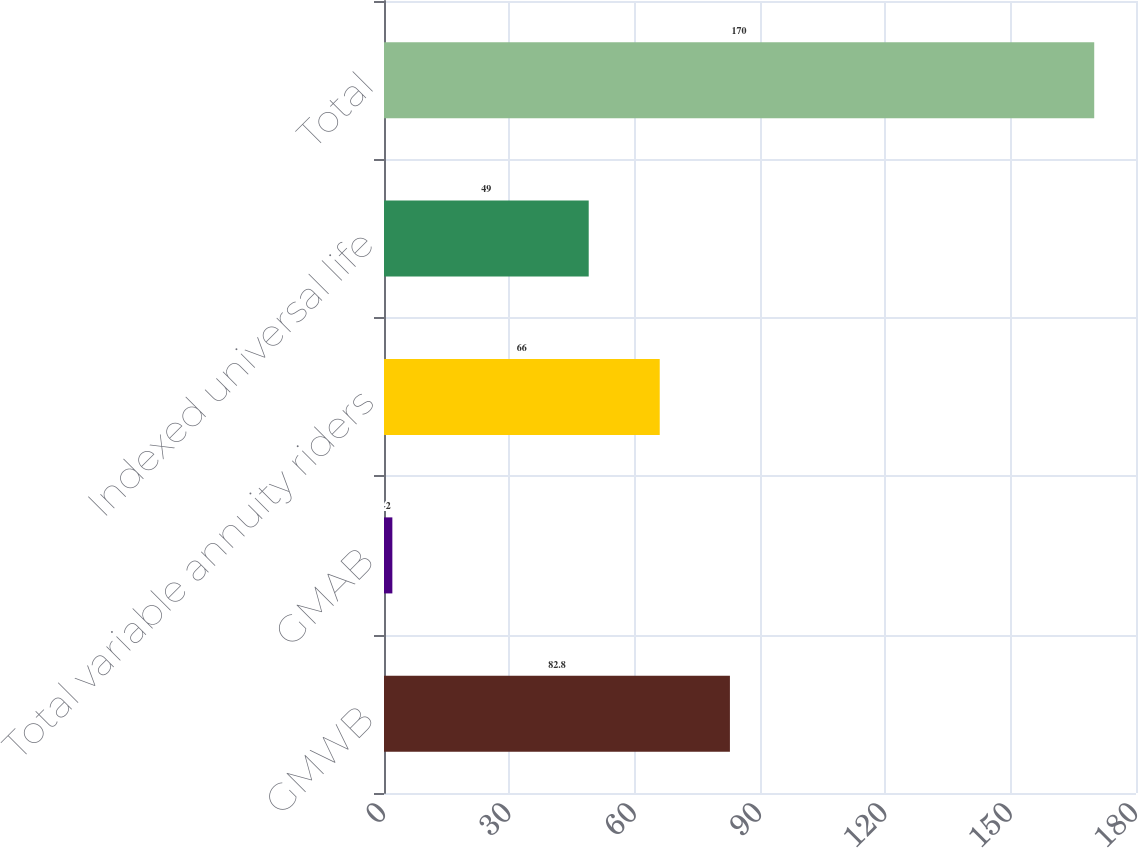Convert chart. <chart><loc_0><loc_0><loc_500><loc_500><bar_chart><fcel>GMWB<fcel>GMAB<fcel>Total variable annuity riders<fcel>Indexed universal life<fcel>Total<nl><fcel>82.8<fcel>2<fcel>66<fcel>49<fcel>170<nl></chart> 